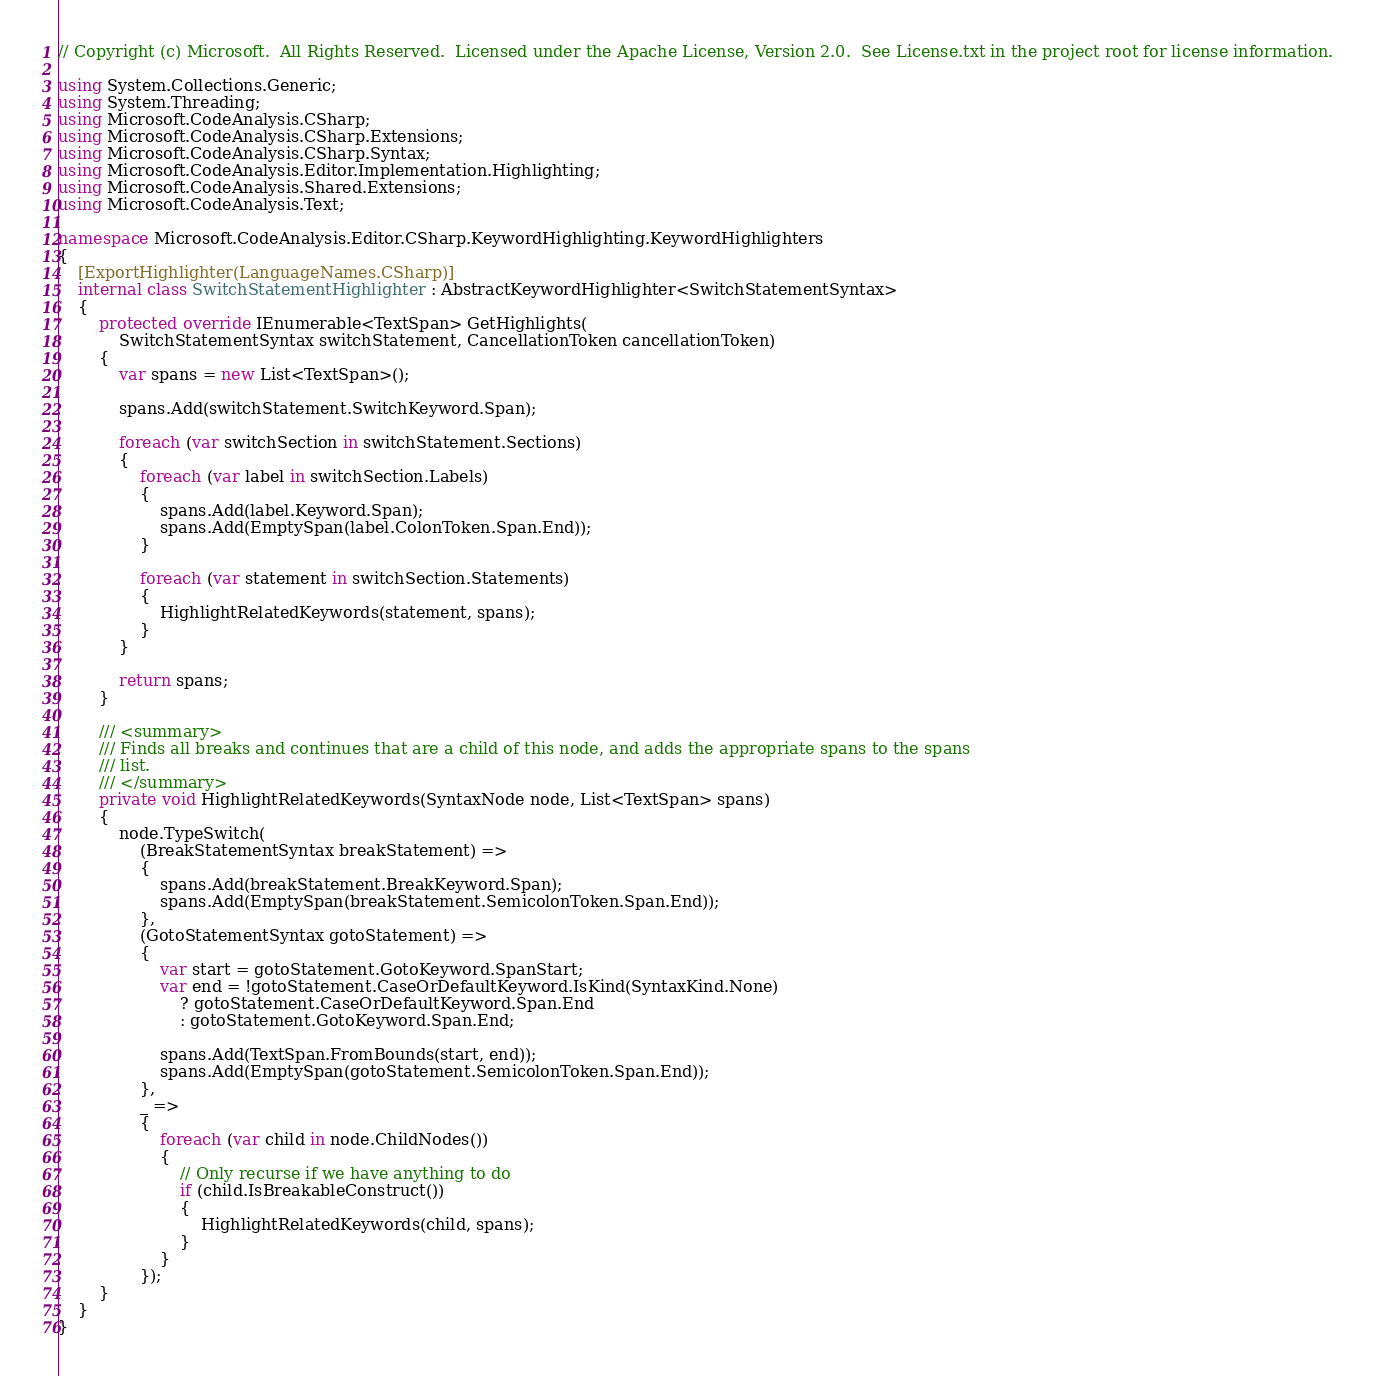Convert code to text. <code><loc_0><loc_0><loc_500><loc_500><_C#_>// Copyright (c) Microsoft.  All Rights Reserved.  Licensed under the Apache License, Version 2.0.  See License.txt in the project root for license information.

using System.Collections.Generic;
using System.Threading;
using Microsoft.CodeAnalysis.CSharp;
using Microsoft.CodeAnalysis.CSharp.Extensions;
using Microsoft.CodeAnalysis.CSharp.Syntax;
using Microsoft.CodeAnalysis.Editor.Implementation.Highlighting;
using Microsoft.CodeAnalysis.Shared.Extensions;
using Microsoft.CodeAnalysis.Text;

namespace Microsoft.CodeAnalysis.Editor.CSharp.KeywordHighlighting.KeywordHighlighters
{
    [ExportHighlighter(LanguageNames.CSharp)]
    internal class SwitchStatementHighlighter : AbstractKeywordHighlighter<SwitchStatementSyntax>
    {
        protected override IEnumerable<TextSpan> GetHighlights(
            SwitchStatementSyntax switchStatement, CancellationToken cancellationToken)
        {
            var spans = new List<TextSpan>();

            spans.Add(switchStatement.SwitchKeyword.Span);

            foreach (var switchSection in switchStatement.Sections)
            {
                foreach (var label in switchSection.Labels)
                {
                    spans.Add(label.Keyword.Span);
                    spans.Add(EmptySpan(label.ColonToken.Span.End));
                }

                foreach (var statement in switchSection.Statements)
                {
                    HighlightRelatedKeywords(statement, spans);
                }
            }

            return spans;
        }

        /// <summary>
        /// Finds all breaks and continues that are a child of this node, and adds the appropriate spans to the spans
        /// list.
        /// </summary>
        private void HighlightRelatedKeywords(SyntaxNode node, List<TextSpan> spans)
        {
            node.TypeSwitch(
                (BreakStatementSyntax breakStatement) =>
                {
                    spans.Add(breakStatement.BreakKeyword.Span);
                    spans.Add(EmptySpan(breakStatement.SemicolonToken.Span.End));
                },
                (GotoStatementSyntax gotoStatement) =>
                {
                    var start = gotoStatement.GotoKeyword.SpanStart;
                    var end = !gotoStatement.CaseOrDefaultKeyword.IsKind(SyntaxKind.None)
                        ? gotoStatement.CaseOrDefaultKeyword.Span.End
                        : gotoStatement.GotoKeyword.Span.End;

                    spans.Add(TextSpan.FromBounds(start, end));
                    spans.Add(EmptySpan(gotoStatement.SemicolonToken.Span.End));
                },
                _ =>
                {
                    foreach (var child in node.ChildNodes())
                    {
                        // Only recurse if we have anything to do
                        if (child.IsBreakableConstruct())
                        {
                            HighlightRelatedKeywords(child, spans);
                        }
                    }
                });
        }
    }
}
</code> 